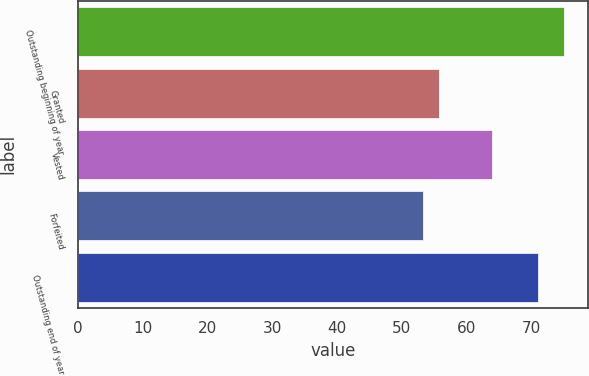<chart> <loc_0><loc_0><loc_500><loc_500><bar_chart><fcel>Outstanding beginning of year<fcel>Granted<fcel>Vested<fcel>Forfeited<fcel>Outstanding end of year<nl><fcel>75.06<fcel>55.71<fcel>63.89<fcel>53.36<fcel>71.03<nl></chart> 